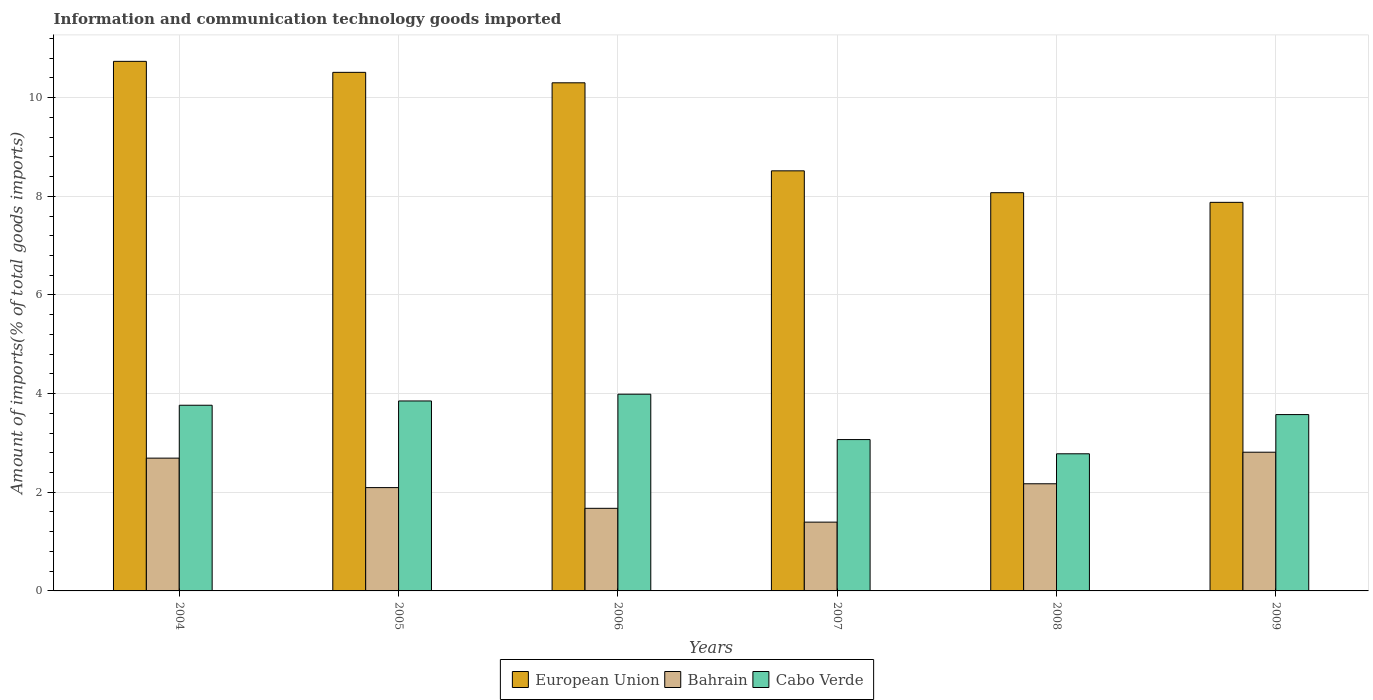How many different coloured bars are there?
Your answer should be very brief. 3. Are the number of bars on each tick of the X-axis equal?
Make the answer very short. Yes. How many bars are there on the 6th tick from the right?
Provide a short and direct response. 3. In how many cases, is the number of bars for a given year not equal to the number of legend labels?
Your answer should be very brief. 0. What is the amount of goods imported in Cabo Verde in 2004?
Offer a very short reply. 3.76. Across all years, what is the maximum amount of goods imported in Bahrain?
Provide a short and direct response. 2.81. Across all years, what is the minimum amount of goods imported in Bahrain?
Your answer should be compact. 1.39. In which year was the amount of goods imported in Cabo Verde minimum?
Provide a short and direct response. 2008. What is the total amount of goods imported in European Union in the graph?
Offer a terse response. 56.02. What is the difference between the amount of goods imported in European Union in 2006 and that in 2007?
Offer a terse response. 1.78. What is the difference between the amount of goods imported in Bahrain in 2005 and the amount of goods imported in European Union in 2006?
Provide a succinct answer. -8.21. What is the average amount of goods imported in Cabo Verde per year?
Your response must be concise. 3.5. In the year 2007, what is the difference between the amount of goods imported in Bahrain and amount of goods imported in European Union?
Ensure brevity in your answer.  -7.12. In how many years, is the amount of goods imported in Bahrain greater than 1.6 %?
Give a very brief answer. 5. What is the ratio of the amount of goods imported in European Union in 2005 to that in 2008?
Your answer should be very brief. 1.3. What is the difference between the highest and the second highest amount of goods imported in Cabo Verde?
Your answer should be compact. 0.14. What is the difference between the highest and the lowest amount of goods imported in European Union?
Your answer should be compact. 2.86. In how many years, is the amount of goods imported in European Union greater than the average amount of goods imported in European Union taken over all years?
Give a very brief answer. 3. What does the 3rd bar from the left in 2009 represents?
Keep it short and to the point. Cabo Verde. What does the 1st bar from the right in 2005 represents?
Ensure brevity in your answer.  Cabo Verde. Is it the case that in every year, the sum of the amount of goods imported in Bahrain and amount of goods imported in Cabo Verde is greater than the amount of goods imported in European Union?
Give a very brief answer. No. Are all the bars in the graph horizontal?
Your response must be concise. No. What is the difference between two consecutive major ticks on the Y-axis?
Make the answer very short. 2. Are the values on the major ticks of Y-axis written in scientific E-notation?
Give a very brief answer. No. Does the graph contain grids?
Provide a succinct answer. Yes. How are the legend labels stacked?
Your answer should be very brief. Horizontal. What is the title of the graph?
Provide a succinct answer. Information and communication technology goods imported. Does "Upper middle income" appear as one of the legend labels in the graph?
Your answer should be very brief. No. What is the label or title of the Y-axis?
Make the answer very short. Amount of imports(% of total goods imports). What is the Amount of imports(% of total goods imports) in European Union in 2004?
Make the answer very short. 10.74. What is the Amount of imports(% of total goods imports) in Bahrain in 2004?
Give a very brief answer. 2.69. What is the Amount of imports(% of total goods imports) of Cabo Verde in 2004?
Your answer should be compact. 3.76. What is the Amount of imports(% of total goods imports) of European Union in 2005?
Provide a succinct answer. 10.51. What is the Amount of imports(% of total goods imports) of Bahrain in 2005?
Your response must be concise. 2.09. What is the Amount of imports(% of total goods imports) of Cabo Verde in 2005?
Provide a short and direct response. 3.85. What is the Amount of imports(% of total goods imports) of European Union in 2006?
Ensure brevity in your answer.  10.3. What is the Amount of imports(% of total goods imports) in Bahrain in 2006?
Your answer should be very brief. 1.67. What is the Amount of imports(% of total goods imports) in Cabo Verde in 2006?
Make the answer very short. 3.99. What is the Amount of imports(% of total goods imports) in European Union in 2007?
Make the answer very short. 8.52. What is the Amount of imports(% of total goods imports) of Bahrain in 2007?
Make the answer very short. 1.39. What is the Amount of imports(% of total goods imports) in Cabo Verde in 2007?
Your response must be concise. 3.07. What is the Amount of imports(% of total goods imports) of European Union in 2008?
Offer a terse response. 8.07. What is the Amount of imports(% of total goods imports) in Bahrain in 2008?
Ensure brevity in your answer.  2.17. What is the Amount of imports(% of total goods imports) of Cabo Verde in 2008?
Your answer should be compact. 2.78. What is the Amount of imports(% of total goods imports) of European Union in 2009?
Your answer should be compact. 7.88. What is the Amount of imports(% of total goods imports) of Bahrain in 2009?
Ensure brevity in your answer.  2.81. What is the Amount of imports(% of total goods imports) in Cabo Verde in 2009?
Your answer should be compact. 3.57. Across all years, what is the maximum Amount of imports(% of total goods imports) of European Union?
Give a very brief answer. 10.74. Across all years, what is the maximum Amount of imports(% of total goods imports) in Bahrain?
Your answer should be very brief. 2.81. Across all years, what is the maximum Amount of imports(% of total goods imports) in Cabo Verde?
Your answer should be very brief. 3.99. Across all years, what is the minimum Amount of imports(% of total goods imports) of European Union?
Provide a short and direct response. 7.88. Across all years, what is the minimum Amount of imports(% of total goods imports) in Bahrain?
Offer a terse response. 1.39. Across all years, what is the minimum Amount of imports(% of total goods imports) of Cabo Verde?
Offer a terse response. 2.78. What is the total Amount of imports(% of total goods imports) of European Union in the graph?
Ensure brevity in your answer.  56.02. What is the total Amount of imports(% of total goods imports) in Bahrain in the graph?
Provide a short and direct response. 12.84. What is the total Amount of imports(% of total goods imports) of Cabo Verde in the graph?
Ensure brevity in your answer.  21.03. What is the difference between the Amount of imports(% of total goods imports) in European Union in 2004 and that in 2005?
Provide a succinct answer. 0.22. What is the difference between the Amount of imports(% of total goods imports) in Bahrain in 2004 and that in 2005?
Provide a short and direct response. 0.6. What is the difference between the Amount of imports(% of total goods imports) in Cabo Verde in 2004 and that in 2005?
Offer a terse response. -0.09. What is the difference between the Amount of imports(% of total goods imports) of European Union in 2004 and that in 2006?
Your answer should be compact. 0.43. What is the difference between the Amount of imports(% of total goods imports) in Bahrain in 2004 and that in 2006?
Your response must be concise. 1.02. What is the difference between the Amount of imports(% of total goods imports) of Cabo Verde in 2004 and that in 2006?
Provide a succinct answer. -0.22. What is the difference between the Amount of imports(% of total goods imports) of European Union in 2004 and that in 2007?
Offer a very short reply. 2.22. What is the difference between the Amount of imports(% of total goods imports) in Bahrain in 2004 and that in 2007?
Your response must be concise. 1.3. What is the difference between the Amount of imports(% of total goods imports) in Cabo Verde in 2004 and that in 2007?
Give a very brief answer. 0.7. What is the difference between the Amount of imports(% of total goods imports) of European Union in 2004 and that in 2008?
Your answer should be compact. 2.66. What is the difference between the Amount of imports(% of total goods imports) in Bahrain in 2004 and that in 2008?
Ensure brevity in your answer.  0.52. What is the difference between the Amount of imports(% of total goods imports) of Cabo Verde in 2004 and that in 2008?
Your answer should be compact. 0.98. What is the difference between the Amount of imports(% of total goods imports) of European Union in 2004 and that in 2009?
Offer a terse response. 2.86. What is the difference between the Amount of imports(% of total goods imports) in Bahrain in 2004 and that in 2009?
Keep it short and to the point. -0.12. What is the difference between the Amount of imports(% of total goods imports) in Cabo Verde in 2004 and that in 2009?
Make the answer very short. 0.19. What is the difference between the Amount of imports(% of total goods imports) of European Union in 2005 and that in 2006?
Provide a succinct answer. 0.21. What is the difference between the Amount of imports(% of total goods imports) of Bahrain in 2005 and that in 2006?
Your answer should be very brief. 0.42. What is the difference between the Amount of imports(% of total goods imports) in Cabo Verde in 2005 and that in 2006?
Provide a short and direct response. -0.14. What is the difference between the Amount of imports(% of total goods imports) of European Union in 2005 and that in 2007?
Give a very brief answer. 2. What is the difference between the Amount of imports(% of total goods imports) of Bahrain in 2005 and that in 2007?
Ensure brevity in your answer.  0.7. What is the difference between the Amount of imports(% of total goods imports) in Cabo Verde in 2005 and that in 2007?
Ensure brevity in your answer.  0.78. What is the difference between the Amount of imports(% of total goods imports) of European Union in 2005 and that in 2008?
Keep it short and to the point. 2.44. What is the difference between the Amount of imports(% of total goods imports) in Bahrain in 2005 and that in 2008?
Ensure brevity in your answer.  -0.08. What is the difference between the Amount of imports(% of total goods imports) of Cabo Verde in 2005 and that in 2008?
Offer a terse response. 1.07. What is the difference between the Amount of imports(% of total goods imports) in European Union in 2005 and that in 2009?
Offer a very short reply. 2.64. What is the difference between the Amount of imports(% of total goods imports) in Bahrain in 2005 and that in 2009?
Give a very brief answer. -0.72. What is the difference between the Amount of imports(% of total goods imports) of Cabo Verde in 2005 and that in 2009?
Ensure brevity in your answer.  0.28. What is the difference between the Amount of imports(% of total goods imports) of European Union in 2006 and that in 2007?
Offer a very short reply. 1.78. What is the difference between the Amount of imports(% of total goods imports) in Bahrain in 2006 and that in 2007?
Make the answer very short. 0.28. What is the difference between the Amount of imports(% of total goods imports) of Cabo Verde in 2006 and that in 2007?
Give a very brief answer. 0.92. What is the difference between the Amount of imports(% of total goods imports) of European Union in 2006 and that in 2008?
Offer a very short reply. 2.23. What is the difference between the Amount of imports(% of total goods imports) of Bahrain in 2006 and that in 2008?
Offer a very short reply. -0.5. What is the difference between the Amount of imports(% of total goods imports) in Cabo Verde in 2006 and that in 2008?
Make the answer very short. 1.21. What is the difference between the Amount of imports(% of total goods imports) of European Union in 2006 and that in 2009?
Offer a very short reply. 2.42. What is the difference between the Amount of imports(% of total goods imports) of Bahrain in 2006 and that in 2009?
Offer a terse response. -1.14. What is the difference between the Amount of imports(% of total goods imports) of Cabo Verde in 2006 and that in 2009?
Keep it short and to the point. 0.41. What is the difference between the Amount of imports(% of total goods imports) of European Union in 2007 and that in 2008?
Give a very brief answer. 0.44. What is the difference between the Amount of imports(% of total goods imports) in Bahrain in 2007 and that in 2008?
Your response must be concise. -0.78. What is the difference between the Amount of imports(% of total goods imports) of Cabo Verde in 2007 and that in 2008?
Ensure brevity in your answer.  0.29. What is the difference between the Amount of imports(% of total goods imports) in European Union in 2007 and that in 2009?
Your answer should be compact. 0.64. What is the difference between the Amount of imports(% of total goods imports) of Bahrain in 2007 and that in 2009?
Make the answer very short. -1.42. What is the difference between the Amount of imports(% of total goods imports) of Cabo Verde in 2007 and that in 2009?
Offer a terse response. -0.51. What is the difference between the Amount of imports(% of total goods imports) of European Union in 2008 and that in 2009?
Keep it short and to the point. 0.2. What is the difference between the Amount of imports(% of total goods imports) of Bahrain in 2008 and that in 2009?
Give a very brief answer. -0.64. What is the difference between the Amount of imports(% of total goods imports) of Cabo Verde in 2008 and that in 2009?
Provide a short and direct response. -0.79. What is the difference between the Amount of imports(% of total goods imports) of European Union in 2004 and the Amount of imports(% of total goods imports) of Bahrain in 2005?
Keep it short and to the point. 8.64. What is the difference between the Amount of imports(% of total goods imports) of European Union in 2004 and the Amount of imports(% of total goods imports) of Cabo Verde in 2005?
Make the answer very short. 6.88. What is the difference between the Amount of imports(% of total goods imports) in Bahrain in 2004 and the Amount of imports(% of total goods imports) in Cabo Verde in 2005?
Provide a short and direct response. -1.16. What is the difference between the Amount of imports(% of total goods imports) of European Union in 2004 and the Amount of imports(% of total goods imports) of Bahrain in 2006?
Ensure brevity in your answer.  9.06. What is the difference between the Amount of imports(% of total goods imports) in European Union in 2004 and the Amount of imports(% of total goods imports) in Cabo Verde in 2006?
Make the answer very short. 6.75. What is the difference between the Amount of imports(% of total goods imports) in Bahrain in 2004 and the Amount of imports(% of total goods imports) in Cabo Verde in 2006?
Provide a short and direct response. -1.3. What is the difference between the Amount of imports(% of total goods imports) in European Union in 2004 and the Amount of imports(% of total goods imports) in Bahrain in 2007?
Provide a short and direct response. 9.34. What is the difference between the Amount of imports(% of total goods imports) of European Union in 2004 and the Amount of imports(% of total goods imports) of Cabo Verde in 2007?
Offer a terse response. 7.67. What is the difference between the Amount of imports(% of total goods imports) in Bahrain in 2004 and the Amount of imports(% of total goods imports) in Cabo Verde in 2007?
Give a very brief answer. -0.38. What is the difference between the Amount of imports(% of total goods imports) of European Union in 2004 and the Amount of imports(% of total goods imports) of Bahrain in 2008?
Ensure brevity in your answer.  8.56. What is the difference between the Amount of imports(% of total goods imports) of European Union in 2004 and the Amount of imports(% of total goods imports) of Cabo Verde in 2008?
Provide a succinct answer. 7.96. What is the difference between the Amount of imports(% of total goods imports) in Bahrain in 2004 and the Amount of imports(% of total goods imports) in Cabo Verde in 2008?
Your answer should be compact. -0.09. What is the difference between the Amount of imports(% of total goods imports) in European Union in 2004 and the Amount of imports(% of total goods imports) in Bahrain in 2009?
Provide a succinct answer. 7.92. What is the difference between the Amount of imports(% of total goods imports) in European Union in 2004 and the Amount of imports(% of total goods imports) in Cabo Verde in 2009?
Make the answer very short. 7.16. What is the difference between the Amount of imports(% of total goods imports) of Bahrain in 2004 and the Amount of imports(% of total goods imports) of Cabo Verde in 2009?
Provide a succinct answer. -0.88. What is the difference between the Amount of imports(% of total goods imports) of European Union in 2005 and the Amount of imports(% of total goods imports) of Bahrain in 2006?
Offer a terse response. 8.84. What is the difference between the Amount of imports(% of total goods imports) of European Union in 2005 and the Amount of imports(% of total goods imports) of Cabo Verde in 2006?
Provide a succinct answer. 6.52. What is the difference between the Amount of imports(% of total goods imports) in Bahrain in 2005 and the Amount of imports(% of total goods imports) in Cabo Verde in 2006?
Offer a very short reply. -1.89. What is the difference between the Amount of imports(% of total goods imports) in European Union in 2005 and the Amount of imports(% of total goods imports) in Bahrain in 2007?
Your answer should be compact. 9.12. What is the difference between the Amount of imports(% of total goods imports) of European Union in 2005 and the Amount of imports(% of total goods imports) of Cabo Verde in 2007?
Provide a short and direct response. 7.44. What is the difference between the Amount of imports(% of total goods imports) of Bahrain in 2005 and the Amount of imports(% of total goods imports) of Cabo Verde in 2007?
Provide a short and direct response. -0.97. What is the difference between the Amount of imports(% of total goods imports) in European Union in 2005 and the Amount of imports(% of total goods imports) in Bahrain in 2008?
Your response must be concise. 8.34. What is the difference between the Amount of imports(% of total goods imports) in European Union in 2005 and the Amount of imports(% of total goods imports) in Cabo Verde in 2008?
Ensure brevity in your answer.  7.73. What is the difference between the Amount of imports(% of total goods imports) in Bahrain in 2005 and the Amount of imports(% of total goods imports) in Cabo Verde in 2008?
Ensure brevity in your answer.  -0.69. What is the difference between the Amount of imports(% of total goods imports) of European Union in 2005 and the Amount of imports(% of total goods imports) of Bahrain in 2009?
Offer a very short reply. 7.7. What is the difference between the Amount of imports(% of total goods imports) in European Union in 2005 and the Amount of imports(% of total goods imports) in Cabo Verde in 2009?
Give a very brief answer. 6.94. What is the difference between the Amount of imports(% of total goods imports) of Bahrain in 2005 and the Amount of imports(% of total goods imports) of Cabo Verde in 2009?
Your answer should be compact. -1.48. What is the difference between the Amount of imports(% of total goods imports) of European Union in 2006 and the Amount of imports(% of total goods imports) of Bahrain in 2007?
Your answer should be very brief. 8.91. What is the difference between the Amount of imports(% of total goods imports) in European Union in 2006 and the Amount of imports(% of total goods imports) in Cabo Verde in 2007?
Your response must be concise. 7.23. What is the difference between the Amount of imports(% of total goods imports) of Bahrain in 2006 and the Amount of imports(% of total goods imports) of Cabo Verde in 2007?
Offer a very short reply. -1.39. What is the difference between the Amount of imports(% of total goods imports) of European Union in 2006 and the Amount of imports(% of total goods imports) of Bahrain in 2008?
Your answer should be compact. 8.13. What is the difference between the Amount of imports(% of total goods imports) of European Union in 2006 and the Amount of imports(% of total goods imports) of Cabo Verde in 2008?
Keep it short and to the point. 7.52. What is the difference between the Amount of imports(% of total goods imports) of Bahrain in 2006 and the Amount of imports(% of total goods imports) of Cabo Verde in 2008?
Keep it short and to the point. -1.11. What is the difference between the Amount of imports(% of total goods imports) of European Union in 2006 and the Amount of imports(% of total goods imports) of Bahrain in 2009?
Offer a terse response. 7.49. What is the difference between the Amount of imports(% of total goods imports) of European Union in 2006 and the Amount of imports(% of total goods imports) of Cabo Verde in 2009?
Make the answer very short. 6.73. What is the difference between the Amount of imports(% of total goods imports) of Bahrain in 2006 and the Amount of imports(% of total goods imports) of Cabo Verde in 2009?
Offer a very short reply. -1.9. What is the difference between the Amount of imports(% of total goods imports) of European Union in 2007 and the Amount of imports(% of total goods imports) of Bahrain in 2008?
Your answer should be compact. 6.34. What is the difference between the Amount of imports(% of total goods imports) of European Union in 2007 and the Amount of imports(% of total goods imports) of Cabo Verde in 2008?
Provide a succinct answer. 5.74. What is the difference between the Amount of imports(% of total goods imports) in Bahrain in 2007 and the Amount of imports(% of total goods imports) in Cabo Verde in 2008?
Offer a terse response. -1.39. What is the difference between the Amount of imports(% of total goods imports) in European Union in 2007 and the Amount of imports(% of total goods imports) in Bahrain in 2009?
Your answer should be very brief. 5.7. What is the difference between the Amount of imports(% of total goods imports) in European Union in 2007 and the Amount of imports(% of total goods imports) in Cabo Verde in 2009?
Offer a very short reply. 4.94. What is the difference between the Amount of imports(% of total goods imports) in Bahrain in 2007 and the Amount of imports(% of total goods imports) in Cabo Verde in 2009?
Your response must be concise. -2.18. What is the difference between the Amount of imports(% of total goods imports) of European Union in 2008 and the Amount of imports(% of total goods imports) of Bahrain in 2009?
Keep it short and to the point. 5.26. What is the difference between the Amount of imports(% of total goods imports) of European Union in 2008 and the Amount of imports(% of total goods imports) of Cabo Verde in 2009?
Offer a terse response. 4.5. What is the difference between the Amount of imports(% of total goods imports) in Bahrain in 2008 and the Amount of imports(% of total goods imports) in Cabo Verde in 2009?
Ensure brevity in your answer.  -1.4. What is the average Amount of imports(% of total goods imports) in European Union per year?
Your answer should be very brief. 9.34. What is the average Amount of imports(% of total goods imports) in Bahrain per year?
Offer a terse response. 2.14. What is the average Amount of imports(% of total goods imports) of Cabo Verde per year?
Your response must be concise. 3.5. In the year 2004, what is the difference between the Amount of imports(% of total goods imports) of European Union and Amount of imports(% of total goods imports) of Bahrain?
Your response must be concise. 8.04. In the year 2004, what is the difference between the Amount of imports(% of total goods imports) of European Union and Amount of imports(% of total goods imports) of Cabo Verde?
Ensure brevity in your answer.  6.97. In the year 2004, what is the difference between the Amount of imports(% of total goods imports) in Bahrain and Amount of imports(% of total goods imports) in Cabo Verde?
Your answer should be compact. -1.07. In the year 2005, what is the difference between the Amount of imports(% of total goods imports) of European Union and Amount of imports(% of total goods imports) of Bahrain?
Provide a succinct answer. 8.42. In the year 2005, what is the difference between the Amount of imports(% of total goods imports) in European Union and Amount of imports(% of total goods imports) in Cabo Verde?
Ensure brevity in your answer.  6.66. In the year 2005, what is the difference between the Amount of imports(% of total goods imports) of Bahrain and Amount of imports(% of total goods imports) of Cabo Verde?
Your answer should be compact. -1.76. In the year 2006, what is the difference between the Amount of imports(% of total goods imports) in European Union and Amount of imports(% of total goods imports) in Bahrain?
Give a very brief answer. 8.63. In the year 2006, what is the difference between the Amount of imports(% of total goods imports) in European Union and Amount of imports(% of total goods imports) in Cabo Verde?
Make the answer very short. 6.31. In the year 2006, what is the difference between the Amount of imports(% of total goods imports) in Bahrain and Amount of imports(% of total goods imports) in Cabo Verde?
Make the answer very short. -2.31. In the year 2007, what is the difference between the Amount of imports(% of total goods imports) of European Union and Amount of imports(% of total goods imports) of Bahrain?
Give a very brief answer. 7.12. In the year 2007, what is the difference between the Amount of imports(% of total goods imports) of European Union and Amount of imports(% of total goods imports) of Cabo Verde?
Keep it short and to the point. 5.45. In the year 2007, what is the difference between the Amount of imports(% of total goods imports) in Bahrain and Amount of imports(% of total goods imports) in Cabo Verde?
Keep it short and to the point. -1.67. In the year 2008, what is the difference between the Amount of imports(% of total goods imports) in European Union and Amount of imports(% of total goods imports) in Bahrain?
Keep it short and to the point. 5.9. In the year 2008, what is the difference between the Amount of imports(% of total goods imports) of European Union and Amount of imports(% of total goods imports) of Cabo Verde?
Give a very brief answer. 5.29. In the year 2008, what is the difference between the Amount of imports(% of total goods imports) of Bahrain and Amount of imports(% of total goods imports) of Cabo Verde?
Keep it short and to the point. -0.61. In the year 2009, what is the difference between the Amount of imports(% of total goods imports) of European Union and Amount of imports(% of total goods imports) of Bahrain?
Provide a short and direct response. 5.07. In the year 2009, what is the difference between the Amount of imports(% of total goods imports) in European Union and Amount of imports(% of total goods imports) in Cabo Verde?
Keep it short and to the point. 4.3. In the year 2009, what is the difference between the Amount of imports(% of total goods imports) in Bahrain and Amount of imports(% of total goods imports) in Cabo Verde?
Your answer should be compact. -0.76. What is the ratio of the Amount of imports(% of total goods imports) of European Union in 2004 to that in 2005?
Your answer should be compact. 1.02. What is the ratio of the Amount of imports(% of total goods imports) in Bahrain in 2004 to that in 2005?
Your answer should be very brief. 1.29. What is the ratio of the Amount of imports(% of total goods imports) in Cabo Verde in 2004 to that in 2005?
Keep it short and to the point. 0.98. What is the ratio of the Amount of imports(% of total goods imports) of European Union in 2004 to that in 2006?
Your response must be concise. 1.04. What is the ratio of the Amount of imports(% of total goods imports) in Bahrain in 2004 to that in 2006?
Provide a succinct answer. 1.61. What is the ratio of the Amount of imports(% of total goods imports) in Cabo Verde in 2004 to that in 2006?
Make the answer very short. 0.94. What is the ratio of the Amount of imports(% of total goods imports) in European Union in 2004 to that in 2007?
Keep it short and to the point. 1.26. What is the ratio of the Amount of imports(% of total goods imports) in Bahrain in 2004 to that in 2007?
Offer a very short reply. 1.93. What is the ratio of the Amount of imports(% of total goods imports) of Cabo Verde in 2004 to that in 2007?
Make the answer very short. 1.23. What is the ratio of the Amount of imports(% of total goods imports) in European Union in 2004 to that in 2008?
Offer a very short reply. 1.33. What is the ratio of the Amount of imports(% of total goods imports) of Bahrain in 2004 to that in 2008?
Your answer should be compact. 1.24. What is the ratio of the Amount of imports(% of total goods imports) in Cabo Verde in 2004 to that in 2008?
Provide a short and direct response. 1.35. What is the ratio of the Amount of imports(% of total goods imports) in European Union in 2004 to that in 2009?
Make the answer very short. 1.36. What is the ratio of the Amount of imports(% of total goods imports) in Bahrain in 2004 to that in 2009?
Ensure brevity in your answer.  0.96. What is the ratio of the Amount of imports(% of total goods imports) of Cabo Verde in 2004 to that in 2009?
Provide a short and direct response. 1.05. What is the ratio of the Amount of imports(% of total goods imports) in European Union in 2005 to that in 2006?
Provide a short and direct response. 1.02. What is the ratio of the Amount of imports(% of total goods imports) of Bahrain in 2005 to that in 2006?
Ensure brevity in your answer.  1.25. What is the ratio of the Amount of imports(% of total goods imports) in Cabo Verde in 2005 to that in 2006?
Offer a terse response. 0.97. What is the ratio of the Amount of imports(% of total goods imports) of European Union in 2005 to that in 2007?
Give a very brief answer. 1.23. What is the ratio of the Amount of imports(% of total goods imports) of Bahrain in 2005 to that in 2007?
Give a very brief answer. 1.5. What is the ratio of the Amount of imports(% of total goods imports) in Cabo Verde in 2005 to that in 2007?
Provide a succinct answer. 1.26. What is the ratio of the Amount of imports(% of total goods imports) of European Union in 2005 to that in 2008?
Your response must be concise. 1.3. What is the ratio of the Amount of imports(% of total goods imports) of Bahrain in 2005 to that in 2008?
Provide a succinct answer. 0.96. What is the ratio of the Amount of imports(% of total goods imports) of Cabo Verde in 2005 to that in 2008?
Keep it short and to the point. 1.39. What is the ratio of the Amount of imports(% of total goods imports) of European Union in 2005 to that in 2009?
Keep it short and to the point. 1.33. What is the ratio of the Amount of imports(% of total goods imports) of Bahrain in 2005 to that in 2009?
Offer a terse response. 0.74. What is the ratio of the Amount of imports(% of total goods imports) in Cabo Verde in 2005 to that in 2009?
Your response must be concise. 1.08. What is the ratio of the Amount of imports(% of total goods imports) in European Union in 2006 to that in 2007?
Keep it short and to the point. 1.21. What is the ratio of the Amount of imports(% of total goods imports) in Bahrain in 2006 to that in 2007?
Your response must be concise. 1.2. What is the ratio of the Amount of imports(% of total goods imports) in Cabo Verde in 2006 to that in 2007?
Your answer should be very brief. 1.3. What is the ratio of the Amount of imports(% of total goods imports) of European Union in 2006 to that in 2008?
Your answer should be very brief. 1.28. What is the ratio of the Amount of imports(% of total goods imports) of Bahrain in 2006 to that in 2008?
Keep it short and to the point. 0.77. What is the ratio of the Amount of imports(% of total goods imports) in Cabo Verde in 2006 to that in 2008?
Your response must be concise. 1.43. What is the ratio of the Amount of imports(% of total goods imports) of European Union in 2006 to that in 2009?
Your answer should be very brief. 1.31. What is the ratio of the Amount of imports(% of total goods imports) of Bahrain in 2006 to that in 2009?
Give a very brief answer. 0.6. What is the ratio of the Amount of imports(% of total goods imports) of Cabo Verde in 2006 to that in 2009?
Provide a succinct answer. 1.12. What is the ratio of the Amount of imports(% of total goods imports) of European Union in 2007 to that in 2008?
Your answer should be very brief. 1.05. What is the ratio of the Amount of imports(% of total goods imports) of Bahrain in 2007 to that in 2008?
Offer a very short reply. 0.64. What is the ratio of the Amount of imports(% of total goods imports) of Cabo Verde in 2007 to that in 2008?
Keep it short and to the point. 1.1. What is the ratio of the Amount of imports(% of total goods imports) of European Union in 2007 to that in 2009?
Provide a succinct answer. 1.08. What is the ratio of the Amount of imports(% of total goods imports) of Bahrain in 2007 to that in 2009?
Provide a succinct answer. 0.5. What is the ratio of the Amount of imports(% of total goods imports) in Cabo Verde in 2007 to that in 2009?
Your answer should be very brief. 0.86. What is the ratio of the Amount of imports(% of total goods imports) of European Union in 2008 to that in 2009?
Provide a short and direct response. 1.02. What is the ratio of the Amount of imports(% of total goods imports) in Bahrain in 2008 to that in 2009?
Offer a terse response. 0.77. What is the ratio of the Amount of imports(% of total goods imports) in Cabo Verde in 2008 to that in 2009?
Keep it short and to the point. 0.78. What is the difference between the highest and the second highest Amount of imports(% of total goods imports) of European Union?
Make the answer very short. 0.22. What is the difference between the highest and the second highest Amount of imports(% of total goods imports) in Bahrain?
Your answer should be very brief. 0.12. What is the difference between the highest and the second highest Amount of imports(% of total goods imports) of Cabo Verde?
Give a very brief answer. 0.14. What is the difference between the highest and the lowest Amount of imports(% of total goods imports) of European Union?
Keep it short and to the point. 2.86. What is the difference between the highest and the lowest Amount of imports(% of total goods imports) of Bahrain?
Offer a terse response. 1.42. What is the difference between the highest and the lowest Amount of imports(% of total goods imports) in Cabo Verde?
Keep it short and to the point. 1.21. 